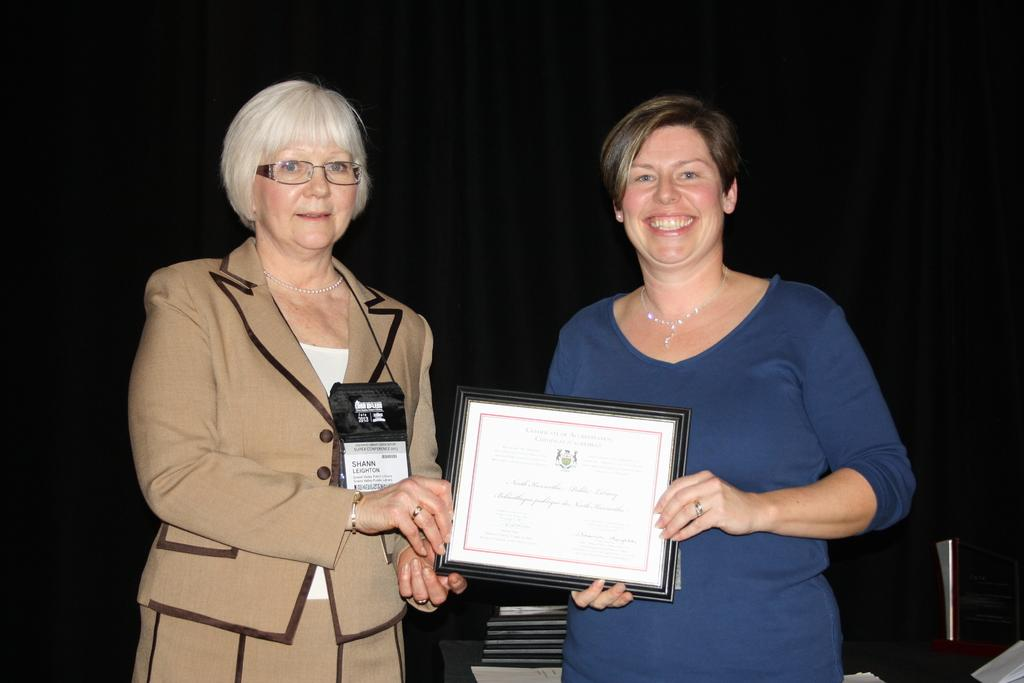How many people are in the image? There are two persons in the image. What are the persons doing in the image? The persons are standing and smiling. What are the persons holding in the image? The persons are holding a certificate. What can be seen in the background of the image? There is a black curtain in the background of the image. Can you see any fog in the image? There is no fog visible in the image. Is there a road present in the image? There is no road visible in the image. 